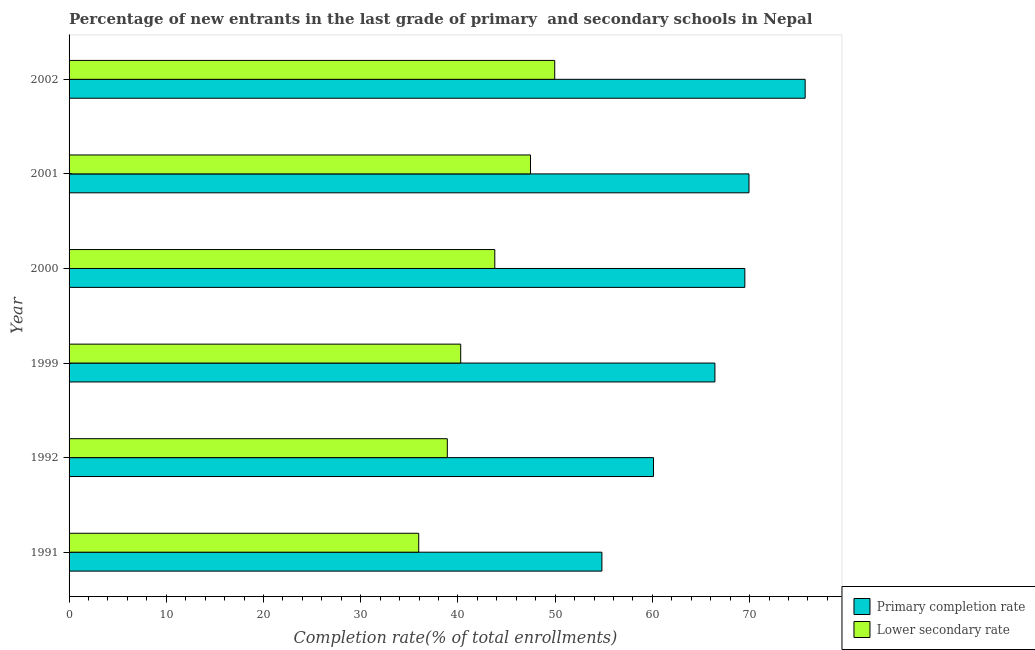What is the label of the 5th group of bars from the top?
Offer a terse response. 1992. What is the completion rate in secondary schools in 2001?
Your response must be concise. 47.46. Across all years, what is the maximum completion rate in primary schools?
Offer a terse response. 75.71. Across all years, what is the minimum completion rate in primary schools?
Keep it short and to the point. 54.8. In which year was the completion rate in secondary schools maximum?
Provide a succinct answer. 2002. What is the total completion rate in primary schools in the graph?
Provide a succinct answer. 396.49. What is the difference between the completion rate in secondary schools in 1999 and that in 2001?
Offer a very short reply. -7.18. What is the difference between the completion rate in secondary schools in 2002 and the completion rate in primary schools in 1992?
Your response must be concise. -10.16. What is the average completion rate in secondary schools per year?
Provide a succinct answer. 42.72. In the year 1999, what is the difference between the completion rate in secondary schools and completion rate in primary schools?
Keep it short and to the point. -26.15. In how many years, is the completion rate in secondary schools greater than 52 %?
Your answer should be very brief. 0. What is the ratio of the completion rate in secondary schools in 1991 to that in 2000?
Provide a succinct answer. 0.82. Is the difference between the completion rate in secondary schools in 1999 and 2000 greater than the difference between the completion rate in primary schools in 1999 and 2000?
Give a very brief answer. No. What is the difference between the highest and the second highest completion rate in primary schools?
Your answer should be compact. 5.78. What is the difference between the highest and the lowest completion rate in primary schools?
Ensure brevity in your answer.  20.91. In how many years, is the completion rate in primary schools greater than the average completion rate in primary schools taken over all years?
Give a very brief answer. 4. Is the sum of the completion rate in primary schools in 2000 and 2001 greater than the maximum completion rate in secondary schools across all years?
Keep it short and to the point. Yes. What does the 2nd bar from the top in 1999 represents?
Keep it short and to the point. Primary completion rate. What does the 1st bar from the bottom in 1992 represents?
Your response must be concise. Primary completion rate. What is the difference between two consecutive major ticks on the X-axis?
Offer a very short reply. 10. Does the graph contain any zero values?
Keep it short and to the point. No. Where does the legend appear in the graph?
Your answer should be compact. Bottom right. How many legend labels are there?
Keep it short and to the point. 2. How are the legend labels stacked?
Your answer should be very brief. Vertical. What is the title of the graph?
Your answer should be very brief. Percentage of new entrants in the last grade of primary  and secondary schools in Nepal. What is the label or title of the X-axis?
Your answer should be very brief. Completion rate(% of total enrollments). What is the Completion rate(% of total enrollments) of Primary completion rate in 1991?
Give a very brief answer. 54.8. What is the Completion rate(% of total enrollments) of Lower secondary rate in 1991?
Keep it short and to the point. 35.96. What is the Completion rate(% of total enrollments) in Primary completion rate in 1992?
Offer a terse response. 60.11. What is the Completion rate(% of total enrollments) in Lower secondary rate in 1992?
Make the answer very short. 38.9. What is the Completion rate(% of total enrollments) in Primary completion rate in 1999?
Keep it short and to the point. 66.43. What is the Completion rate(% of total enrollments) of Lower secondary rate in 1999?
Your answer should be compact. 40.28. What is the Completion rate(% of total enrollments) of Primary completion rate in 2000?
Your response must be concise. 69.51. What is the Completion rate(% of total enrollments) in Lower secondary rate in 2000?
Provide a succinct answer. 43.79. What is the Completion rate(% of total enrollments) of Primary completion rate in 2001?
Keep it short and to the point. 69.93. What is the Completion rate(% of total enrollments) of Lower secondary rate in 2001?
Offer a terse response. 47.46. What is the Completion rate(% of total enrollments) of Primary completion rate in 2002?
Keep it short and to the point. 75.71. What is the Completion rate(% of total enrollments) of Lower secondary rate in 2002?
Offer a very short reply. 49.95. Across all years, what is the maximum Completion rate(% of total enrollments) of Primary completion rate?
Your response must be concise. 75.71. Across all years, what is the maximum Completion rate(% of total enrollments) in Lower secondary rate?
Make the answer very short. 49.95. Across all years, what is the minimum Completion rate(% of total enrollments) of Primary completion rate?
Your answer should be compact. 54.8. Across all years, what is the minimum Completion rate(% of total enrollments) of Lower secondary rate?
Offer a very short reply. 35.96. What is the total Completion rate(% of total enrollments) of Primary completion rate in the graph?
Offer a terse response. 396.49. What is the total Completion rate(% of total enrollments) in Lower secondary rate in the graph?
Offer a terse response. 256.34. What is the difference between the Completion rate(% of total enrollments) of Primary completion rate in 1991 and that in 1992?
Offer a very short reply. -5.3. What is the difference between the Completion rate(% of total enrollments) of Lower secondary rate in 1991 and that in 1992?
Provide a succinct answer. -2.94. What is the difference between the Completion rate(% of total enrollments) in Primary completion rate in 1991 and that in 1999?
Give a very brief answer. -11.62. What is the difference between the Completion rate(% of total enrollments) of Lower secondary rate in 1991 and that in 1999?
Give a very brief answer. -4.32. What is the difference between the Completion rate(% of total enrollments) in Primary completion rate in 1991 and that in 2000?
Give a very brief answer. -14.7. What is the difference between the Completion rate(% of total enrollments) of Lower secondary rate in 1991 and that in 2000?
Your answer should be very brief. -7.83. What is the difference between the Completion rate(% of total enrollments) in Primary completion rate in 1991 and that in 2001?
Ensure brevity in your answer.  -15.13. What is the difference between the Completion rate(% of total enrollments) in Lower secondary rate in 1991 and that in 2001?
Give a very brief answer. -11.5. What is the difference between the Completion rate(% of total enrollments) in Primary completion rate in 1991 and that in 2002?
Provide a succinct answer. -20.91. What is the difference between the Completion rate(% of total enrollments) of Lower secondary rate in 1991 and that in 2002?
Ensure brevity in your answer.  -13.99. What is the difference between the Completion rate(% of total enrollments) of Primary completion rate in 1992 and that in 1999?
Make the answer very short. -6.32. What is the difference between the Completion rate(% of total enrollments) of Lower secondary rate in 1992 and that in 1999?
Your answer should be very brief. -1.38. What is the difference between the Completion rate(% of total enrollments) in Primary completion rate in 1992 and that in 2000?
Your response must be concise. -9.4. What is the difference between the Completion rate(% of total enrollments) of Lower secondary rate in 1992 and that in 2000?
Make the answer very short. -4.88. What is the difference between the Completion rate(% of total enrollments) in Primary completion rate in 1992 and that in 2001?
Offer a terse response. -9.82. What is the difference between the Completion rate(% of total enrollments) in Lower secondary rate in 1992 and that in 2001?
Offer a very short reply. -8.56. What is the difference between the Completion rate(% of total enrollments) of Primary completion rate in 1992 and that in 2002?
Offer a very short reply. -15.6. What is the difference between the Completion rate(% of total enrollments) in Lower secondary rate in 1992 and that in 2002?
Offer a terse response. -11.05. What is the difference between the Completion rate(% of total enrollments) in Primary completion rate in 1999 and that in 2000?
Provide a short and direct response. -3.08. What is the difference between the Completion rate(% of total enrollments) in Lower secondary rate in 1999 and that in 2000?
Offer a terse response. -3.51. What is the difference between the Completion rate(% of total enrollments) of Primary completion rate in 1999 and that in 2001?
Make the answer very short. -3.5. What is the difference between the Completion rate(% of total enrollments) of Lower secondary rate in 1999 and that in 2001?
Give a very brief answer. -7.18. What is the difference between the Completion rate(% of total enrollments) of Primary completion rate in 1999 and that in 2002?
Your answer should be compact. -9.28. What is the difference between the Completion rate(% of total enrollments) in Lower secondary rate in 1999 and that in 2002?
Make the answer very short. -9.67. What is the difference between the Completion rate(% of total enrollments) of Primary completion rate in 2000 and that in 2001?
Your answer should be compact. -0.43. What is the difference between the Completion rate(% of total enrollments) in Lower secondary rate in 2000 and that in 2001?
Offer a very short reply. -3.67. What is the difference between the Completion rate(% of total enrollments) of Primary completion rate in 2000 and that in 2002?
Give a very brief answer. -6.2. What is the difference between the Completion rate(% of total enrollments) in Lower secondary rate in 2000 and that in 2002?
Your response must be concise. -6.16. What is the difference between the Completion rate(% of total enrollments) of Primary completion rate in 2001 and that in 2002?
Provide a short and direct response. -5.78. What is the difference between the Completion rate(% of total enrollments) in Lower secondary rate in 2001 and that in 2002?
Provide a short and direct response. -2.49. What is the difference between the Completion rate(% of total enrollments) in Primary completion rate in 1991 and the Completion rate(% of total enrollments) in Lower secondary rate in 1992?
Keep it short and to the point. 15.9. What is the difference between the Completion rate(% of total enrollments) of Primary completion rate in 1991 and the Completion rate(% of total enrollments) of Lower secondary rate in 1999?
Keep it short and to the point. 14.52. What is the difference between the Completion rate(% of total enrollments) in Primary completion rate in 1991 and the Completion rate(% of total enrollments) in Lower secondary rate in 2000?
Your answer should be compact. 11.02. What is the difference between the Completion rate(% of total enrollments) in Primary completion rate in 1991 and the Completion rate(% of total enrollments) in Lower secondary rate in 2001?
Offer a very short reply. 7.34. What is the difference between the Completion rate(% of total enrollments) in Primary completion rate in 1991 and the Completion rate(% of total enrollments) in Lower secondary rate in 2002?
Make the answer very short. 4.85. What is the difference between the Completion rate(% of total enrollments) of Primary completion rate in 1992 and the Completion rate(% of total enrollments) of Lower secondary rate in 1999?
Your answer should be compact. 19.83. What is the difference between the Completion rate(% of total enrollments) in Primary completion rate in 1992 and the Completion rate(% of total enrollments) in Lower secondary rate in 2000?
Make the answer very short. 16.32. What is the difference between the Completion rate(% of total enrollments) in Primary completion rate in 1992 and the Completion rate(% of total enrollments) in Lower secondary rate in 2001?
Your response must be concise. 12.65. What is the difference between the Completion rate(% of total enrollments) in Primary completion rate in 1992 and the Completion rate(% of total enrollments) in Lower secondary rate in 2002?
Give a very brief answer. 10.16. What is the difference between the Completion rate(% of total enrollments) in Primary completion rate in 1999 and the Completion rate(% of total enrollments) in Lower secondary rate in 2000?
Provide a succinct answer. 22.64. What is the difference between the Completion rate(% of total enrollments) of Primary completion rate in 1999 and the Completion rate(% of total enrollments) of Lower secondary rate in 2001?
Offer a terse response. 18.97. What is the difference between the Completion rate(% of total enrollments) of Primary completion rate in 1999 and the Completion rate(% of total enrollments) of Lower secondary rate in 2002?
Provide a short and direct response. 16.48. What is the difference between the Completion rate(% of total enrollments) of Primary completion rate in 2000 and the Completion rate(% of total enrollments) of Lower secondary rate in 2001?
Provide a succinct answer. 22.05. What is the difference between the Completion rate(% of total enrollments) of Primary completion rate in 2000 and the Completion rate(% of total enrollments) of Lower secondary rate in 2002?
Make the answer very short. 19.56. What is the difference between the Completion rate(% of total enrollments) in Primary completion rate in 2001 and the Completion rate(% of total enrollments) in Lower secondary rate in 2002?
Offer a very short reply. 19.98. What is the average Completion rate(% of total enrollments) in Primary completion rate per year?
Make the answer very short. 66.08. What is the average Completion rate(% of total enrollments) in Lower secondary rate per year?
Offer a terse response. 42.72. In the year 1991, what is the difference between the Completion rate(% of total enrollments) of Primary completion rate and Completion rate(% of total enrollments) of Lower secondary rate?
Make the answer very short. 18.84. In the year 1992, what is the difference between the Completion rate(% of total enrollments) of Primary completion rate and Completion rate(% of total enrollments) of Lower secondary rate?
Your answer should be compact. 21.2. In the year 1999, what is the difference between the Completion rate(% of total enrollments) of Primary completion rate and Completion rate(% of total enrollments) of Lower secondary rate?
Offer a terse response. 26.15. In the year 2000, what is the difference between the Completion rate(% of total enrollments) in Primary completion rate and Completion rate(% of total enrollments) in Lower secondary rate?
Your answer should be very brief. 25.72. In the year 2001, what is the difference between the Completion rate(% of total enrollments) in Primary completion rate and Completion rate(% of total enrollments) in Lower secondary rate?
Keep it short and to the point. 22.47. In the year 2002, what is the difference between the Completion rate(% of total enrollments) in Primary completion rate and Completion rate(% of total enrollments) in Lower secondary rate?
Make the answer very short. 25.76. What is the ratio of the Completion rate(% of total enrollments) of Primary completion rate in 1991 to that in 1992?
Keep it short and to the point. 0.91. What is the ratio of the Completion rate(% of total enrollments) of Lower secondary rate in 1991 to that in 1992?
Give a very brief answer. 0.92. What is the ratio of the Completion rate(% of total enrollments) in Primary completion rate in 1991 to that in 1999?
Offer a terse response. 0.82. What is the ratio of the Completion rate(% of total enrollments) of Lower secondary rate in 1991 to that in 1999?
Your response must be concise. 0.89. What is the ratio of the Completion rate(% of total enrollments) in Primary completion rate in 1991 to that in 2000?
Keep it short and to the point. 0.79. What is the ratio of the Completion rate(% of total enrollments) of Lower secondary rate in 1991 to that in 2000?
Provide a succinct answer. 0.82. What is the ratio of the Completion rate(% of total enrollments) of Primary completion rate in 1991 to that in 2001?
Offer a very short reply. 0.78. What is the ratio of the Completion rate(% of total enrollments) in Lower secondary rate in 1991 to that in 2001?
Offer a very short reply. 0.76. What is the ratio of the Completion rate(% of total enrollments) of Primary completion rate in 1991 to that in 2002?
Offer a terse response. 0.72. What is the ratio of the Completion rate(% of total enrollments) in Lower secondary rate in 1991 to that in 2002?
Make the answer very short. 0.72. What is the ratio of the Completion rate(% of total enrollments) in Primary completion rate in 1992 to that in 1999?
Your response must be concise. 0.9. What is the ratio of the Completion rate(% of total enrollments) of Lower secondary rate in 1992 to that in 1999?
Keep it short and to the point. 0.97. What is the ratio of the Completion rate(% of total enrollments) of Primary completion rate in 1992 to that in 2000?
Offer a very short reply. 0.86. What is the ratio of the Completion rate(% of total enrollments) of Lower secondary rate in 1992 to that in 2000?
Your answer should be very brief. 0.89. What is the ratio of the Completion rate(% of total enrollments) in Primary completion rate in 1992 to that in 2001?
Make the answer very short. 0.86. What is the ratio of the Completion rate(% of total enrollments) of Lower secondary rate in 1992 to that in 2001?
Provide a short and direct response. 0.82. What is the ratio of the Completion rate(% of total enrollments) of Primary completion rate in 1992 to that in 2002?
Give a very brief answer. 0.79. What is the ratio of the Completion rate(% of total enrollments) of Lower secondary rate in 1992 to that in 2002?
Keep it short and to the point. 0.78. What is the ratio of the Completion rate(% of total enrollments) of Primary completion rate in 1999 to that in 2000?
Offer a terse response. 0.96. What is the ratio of the Completion rate(% of total enrollments) in Lower secondary rate in 1999 to that in 2000?
Offer a very short reply. 0.92. What is the ratio of the Completion rate(% of total enrollments) of Primary completion rate in 1999 to that in 2001?
Offer a very short reply. 0.95. What is the ratio of the Completion rate(% of total enrollments) of Lower secondary rate in 1999 to that in 2001?
Offer a terse response. 0.85. What is the ratio of the Completion rate(% of total enrollments) of Primary completion rate in 1999 to that in 2002?
Offer a very short reply. 0.88. What is the ratio of the Completion rate(% of total enrollments) of Lower secondary rate in 1999 to that in 2002?
Ensure brevity in your answer.  0.81. What is the ratio of the Completion rate(% of total enrollments) of Lower secondary rate in 2000 to that in 2001?
Ensure brevity in your answer.  0.92. What is the ratio of the Completion rate(% of total enrollments) in Primary completion rate in 2000 to that in 2002?
Provide a succinct answer. 0.92. What is the ratio of the Completion rate(% of total enrollments) in Lower secondary rate in 2000 to that in 2002?
Make the answer very short. 0.88. What is the ratio of the Completion rate(% of total enrollments) of Primary completion rate in 2001 to that in 2002?
Make the answer very short. 0.92. What is the ratio of the Completion rate(% of total enrollments) of Lower secondary rate in 2001 to that in 2002?
Provide a short and direct response. 0.95. What is the difference between the highest and the second highest Completion rate(% of total enrollments) of Primary completion rate?
Your answer should be compact. 5.78. What is the difference between the highest and the second highest Completion rate(% of total enrollments) in Lower secondary rate?
Provide a short and direct response. 2.49. What is the difference between the highest and the lowest Completion rate(% of total enrollments) of Primary completion rate?
Make the answer very short. 20.91. What is the difference between the highest and the lowest Completion rate(% of total enrollments) in Lower secondary rate?
Keep it short and to the point. 13.99. 